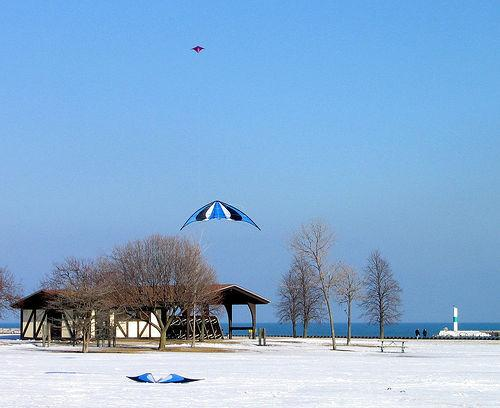Provide an impression of the atmosphere presented in the image. The image depicts a peaceful, relaxed, and vibrant beach scene with kites flying and people walking. Choose 3 main objects from the image: state what they are and describe them briefly. Kites of various colors flying and on the ground, leafless trees standing tall, and a small brown and white building by the beach. In one sentence, describe the most striking feature in the image. Colorful kites dance in a cloudless blue sky above a sandy beach adorned with leafless trees. List 5 key elements that can be observed in the picture. Beach, ocean, kites, leafless trees, blue sky. State 2-3 primary features of the image and give their locations. A group of leafless trees on the left, white sandy beach towards the bottom, and various kites in the sky and ground at the center. Mention the top 5 components observed in the image from the most to least important. Kites both flying and on the ground, people walking on the beach, sandy beach, ocean, group of trees. Provide a creative and descriptive narrative about the scene in the image. Imagine a serene beach scene, kites soaring gracefully in the crystal clear sky, while people stroll by the ocean's blue waters and leafless trees watch silently beside a cozy beach pavilion. Mention the colors and objects that make the image visually appealing. The vibrant colors of the kites, the azure blue sky, and the contrasts of sand, ocean, and trees. Write a short description of the key elements in the image. There's a clear blue sky, sandy beach, and ocean, with kites flying and laying on the ground, leafless trees, and a brown and white building. Share a brief observation of the people and the environment in the picture. People leisurely walk by the ocean, while kites punctuate the clear blue sky, amidst leafless trees and a sandy beach. 